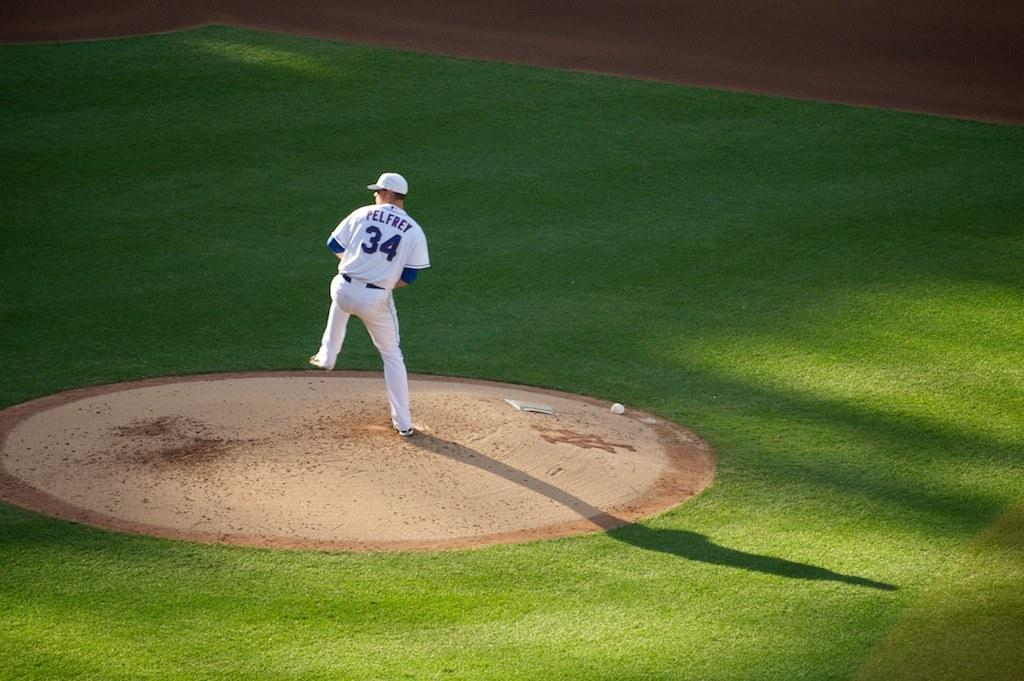Provide a one-sentence caption for the provided image. Baseball player Pelfrey gets ready to throw the ball. 